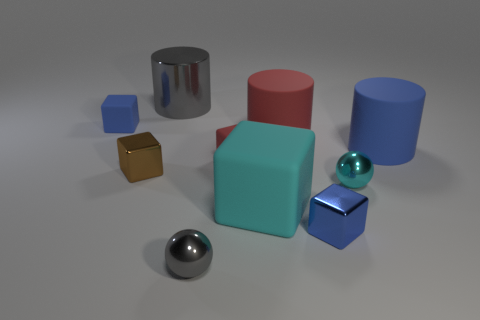Subtract all red blocks. How many blocks are left? 4 Subtract all red blocks. How many blocks are left? 4 Subtract all red blocks. Subtract all brown balls. How many blocks are left? 4 Subtract all balls. How many objects are left? 8 Subtract 0 green balls. How many objects are left? 10 Subtract all tiny gray things. Subtract all big brown rubber cylinders. How many objects are left? 9 Add 7 blue cylinders. How many blue cylinders are left? 8 Add 7 big metal cylinders. How many big metal cylinders exist? 8 